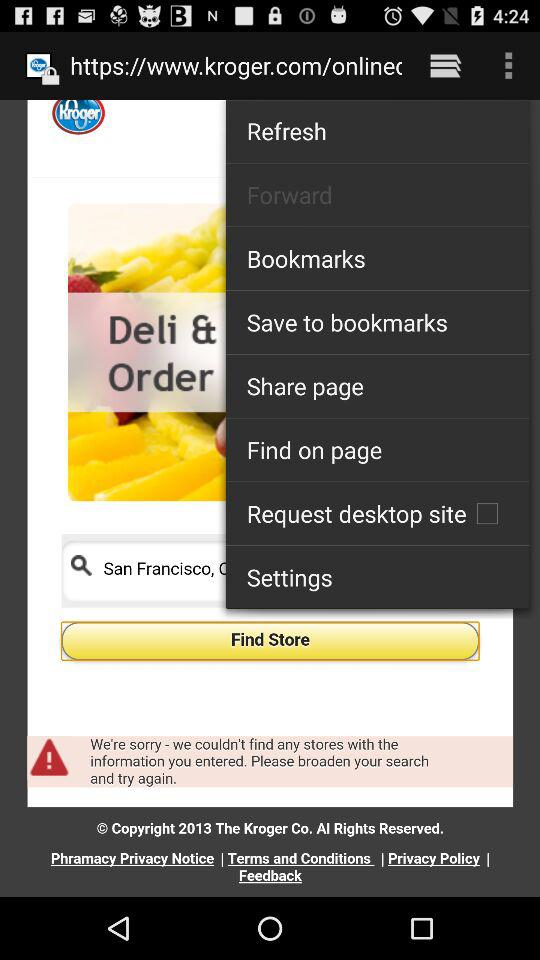What is the status of the "Request desktop site" setting? The status is "off". 